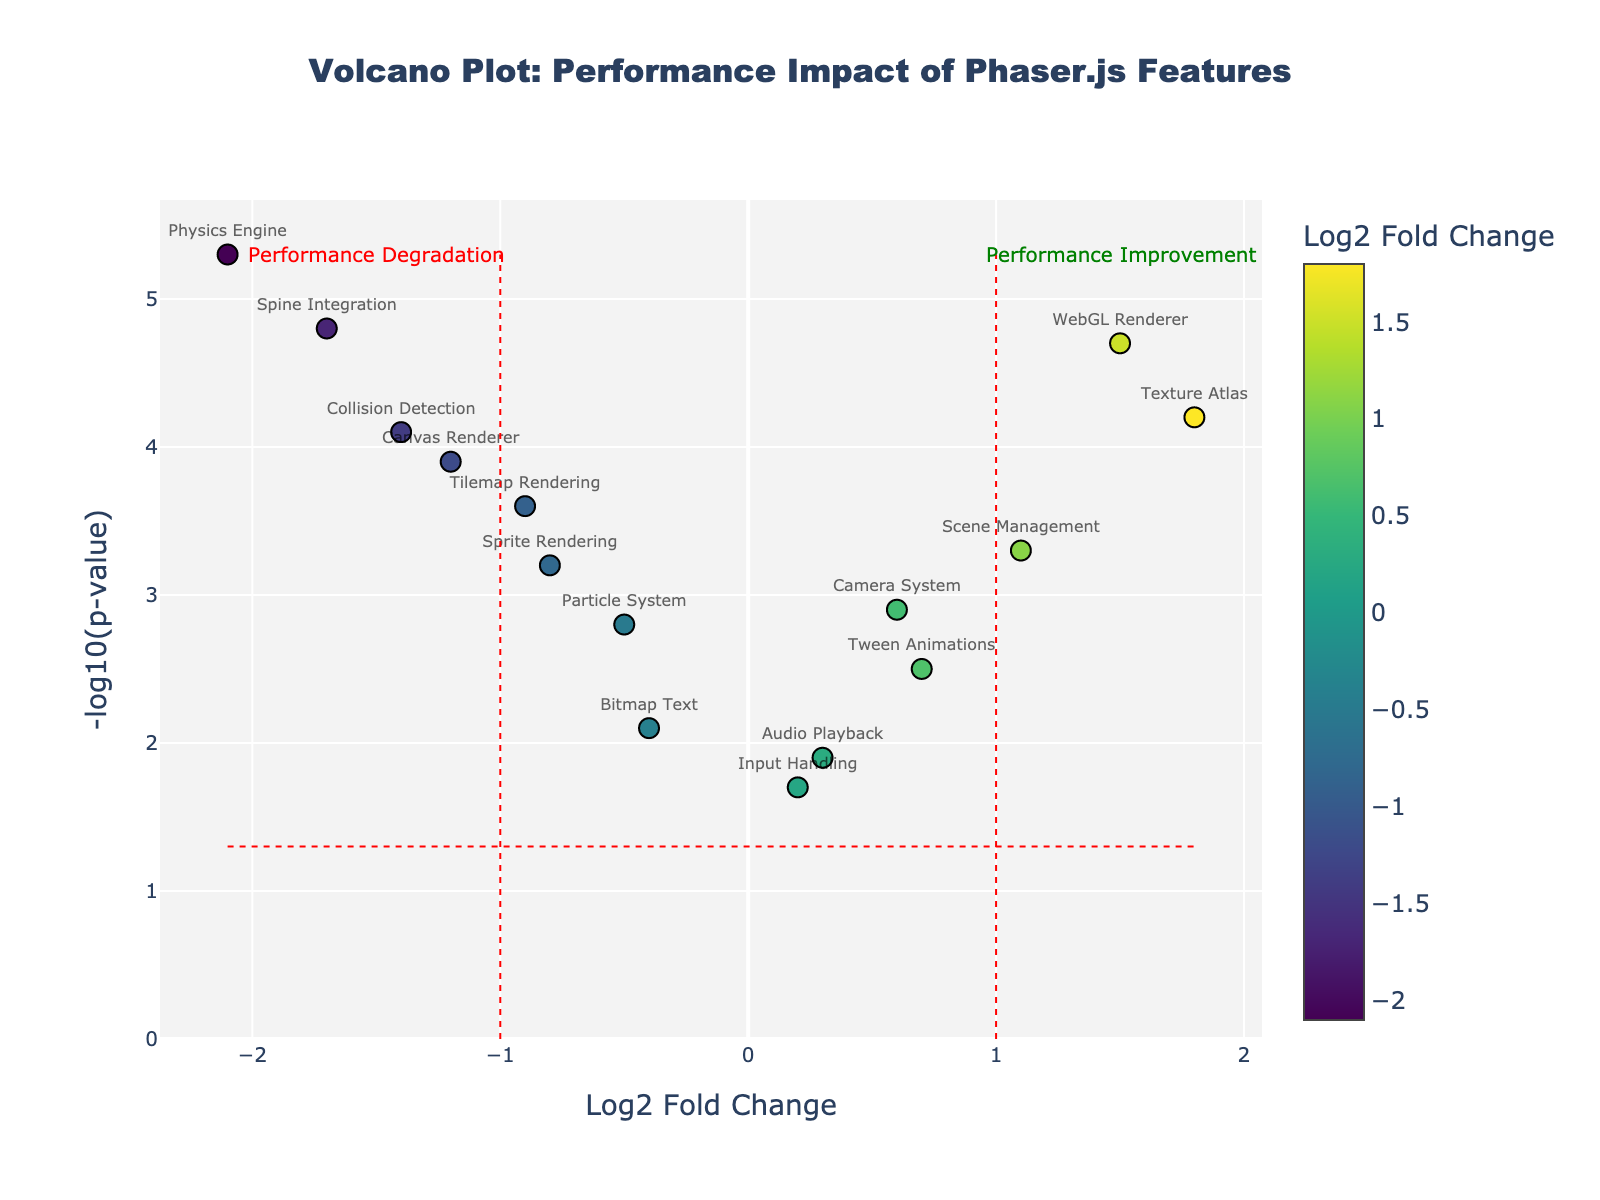What is the title of the figure? The title of the figure is displayed at the top and reads "Volcano Plot: Performance Impact of Phaser.js Features".
Answer: Volcano Plot: Performance Impact of Phaser.js Features What do the x-axis and y-axis represent in this plot? The x-axis represents the Log2 Fold Change, and the y-axis represents the -log10(p-value). This can be seen from the labels on the axes.
Answer: The x-axis shows log2 fold change, and the y-axis shows -log10(p-value) How many data points are displayed in the figure? We can count each marker representing a feature label to determine the number of data points. By counting the labeled markers, there are 15 data points.
Answer: 15 Which feature shows the most significant performance degradation? Look for the feature with the highest value on the y-axis in the negative log2 fold change region (left side). The Physics Engine has the highest -log10(p-value) at a value of 5.3.
Answer: Physics Engine Which feature shows the maximum performance improvement? Look for the feature with the highest value on the y-axis in the positive log2 fold change region (right side). The WebGL Renderer has the highest -log10(p-value) at a value of 4.7.
Answer: WebGL Renderer What is the significance threshold indicated on the plot? The significance threshold is shown by a horizontal dotted red line. According to the code, this is at -log10(p-value) = -log10(0.05), which is approximately 1.3.
Answer: 1.3 Which feature has the highest -log10(p-value) but indicates performance degradation? Check the negative log2 fold change region for the feature with the highest y-value. The Physics Engine, with a -log10(p-value) of 5.3, fits this description.
Answer: Physics Engine Are there any features with a log2 fold change close to zero but still significant? Look near the x-axis center (log2 fold change close to 0) for points above the significance threshold (approximately 1.3). Audio Playback (0.3, 1.9) and Input Handling (0.2, 1.7) are close to zero but have significant p-values.
Answer: Yes, Audio Playback and Input Handling What range of log2 fold change values is considered a significant performance impact? Since the plot uses lines at log2 fold changes of -1 and 1 to indicate thresholds for significant impact, values below -1 or above 1 are considered significant impacts.
Answer: Less than -1 or greater than 1 